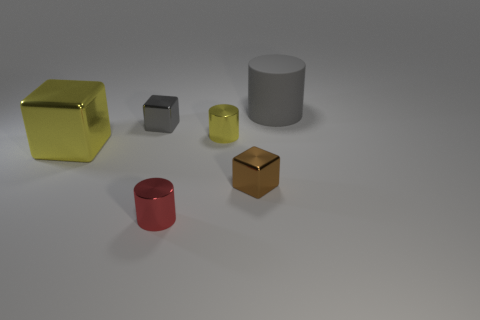Are there any other things that have the same material as the large gray cylinder?
Provide a short and direct response. No. There is a thing that is the same color as the large cylinder; what material is it?
Offer a terse response. Metal. Are there any other things that are the same shape as the large yellow thing?
Make the answer very short. Yes. There is a gray object that is to the right of the brown metallic object; what is its material?
Your answer should be very brief. Rubber. Is the large object that is on the right side of the brown block made of the same material as the tiny red thing?
Offer a terse response. No. How many objects are big gray cylinders or tiny cubes behind the tiny yellow cylinder?
Keep it short and to the point. 2. The gray shiny thing that is the same shape as the brown object is what size?
Give a very brief answer. Small. Are there any gray things on the left side of the small brown object?
Give a very brief answer. Yes. There is a block that is on the left side of the gray cube; is it the same color as the small metallic cube behind the yellow metallic cylinder?
Ensure brevity in your answer.  No. Is there another small brown shiny thing that has the same shape as the tiny brown metal thing?
Your response must be concise. No. 